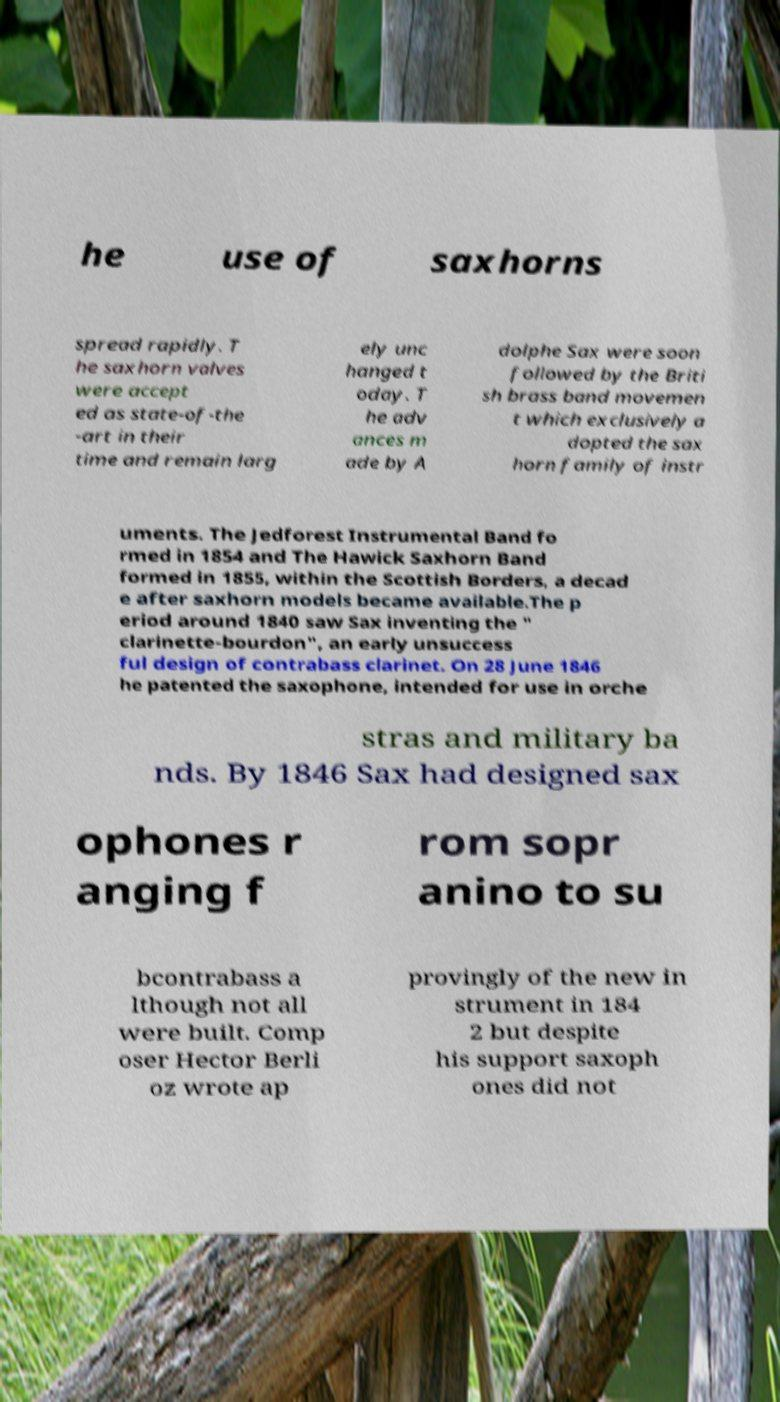Could you assist in decoding the text presented in this image and type it out clearly? he use of saxhorns spread rapidly. T he saxhorn valves were accept ed as state-of-the -art in their time and remain larg ely unc hanged t oday. T he adv ances m ade by A dolphe Sax were soon followed by the Briti sh brass band movemen t which exclusively a dopted the sax horn family of instr uments. The Jedforest Instrumental Band fo rmed in 1854 and The Hawick Saxhorn Band formed in 1855, within the Scottish Borders, a decad e after saxhorn models became available.The p eriod around 1840 saw Sax inventing the " clarinette-bourdon", an early unsuccess ful design of contrabass clarinet. On 28 June 1846 he patented the saxophone, intended for use in orche stras and military ba nds. By 1846 Sax had designed sax ophones r anging f rom sopr anino to su bcontrabass a lthough not all were built. Comp oser Hector Berli oz wrote ap provingly of the new in strument in 184 2 but despite his support saxoph ones did not 